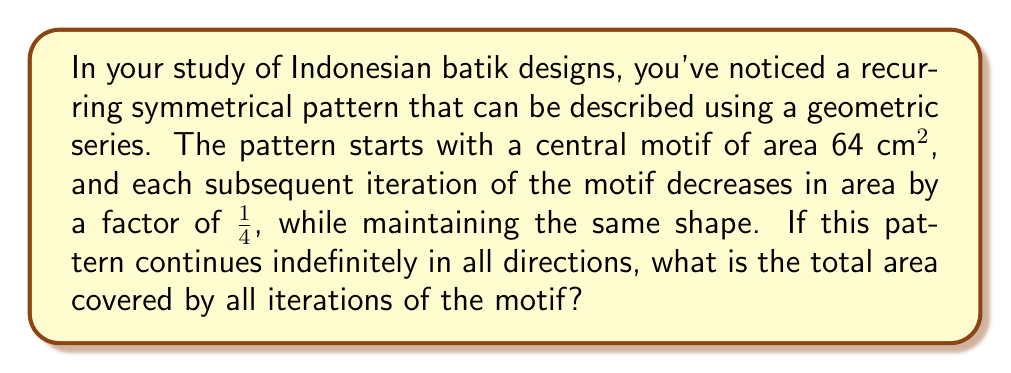Give your solution to this math problem. To solve this problem, we need to use the concept of geometric series and its sum to infinity. Let's break it down step by step:

1) First, let's identify the components of our geometric series:
   - Initial term (a): 64 cm²
   - Common ratio (r): 1/4

2) The formula for the sum of an infinite geometric series where |r| < 1 is:

   $$ S_{\infty} = \frac{a}{1-r} $$

   where $S_{\infty}$ is the sum to infinity, $a$ is the first term, and $r$ is the common ratio.

3) In our case:
   $a = 64$ cm²
   $r = \frac{1}{4} = 0.25$

4) Let's verify that |r| < 1:
   $|\frac{1}{4}| = 0.25 < 1$, so we can use the formula.

5) Now, let's substitute these values into our formula:

   $$ S_{\infty} = \frac{64}{1-\frac{1}{4}} = \frac{64}{\frac{3}{4}} $$

6) Simplify:
   $$ S_{\infty} = 64 \cdot \frac{4}{3} = \frac{256}{3} \approx 85.33 \text{ cm}² $$

This result represents the sum of the areas of all iterations of the motif in one direction. However, the question states that the pattern continues indefinitely in all directions.

7) To account for this, we need to multiply our result by 4 (for the four quadrants of a 2D plane):

   $$ \text{Total Area} = 4 \cdot \frac{256}{3} = \frac{1024}{3} \approx 341.33 \text{ cm}² $$

Therefore, the total area covered by all iterations of the motif in all directions is $\frac{1024}{3}$ cm².
Answer: $\frac{1024}{3}$ cm² or approximately 341.33 cm² 